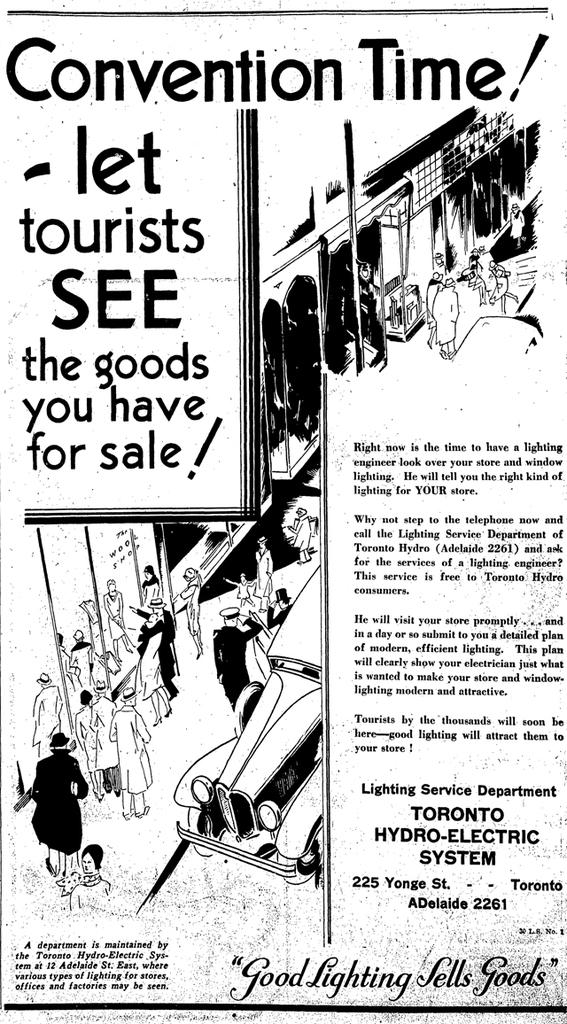What is present in the image that contains both text and images? There is a poster in the image that contains text and images. Can you describe the content of the poster? The poster contains text and images, but the specific content cannot be determined from the provided facts. How many chickens are depicted on the poster? There is no mention of chickens in the provided facts, so it cannot be determined if any are depicted on the poster. 